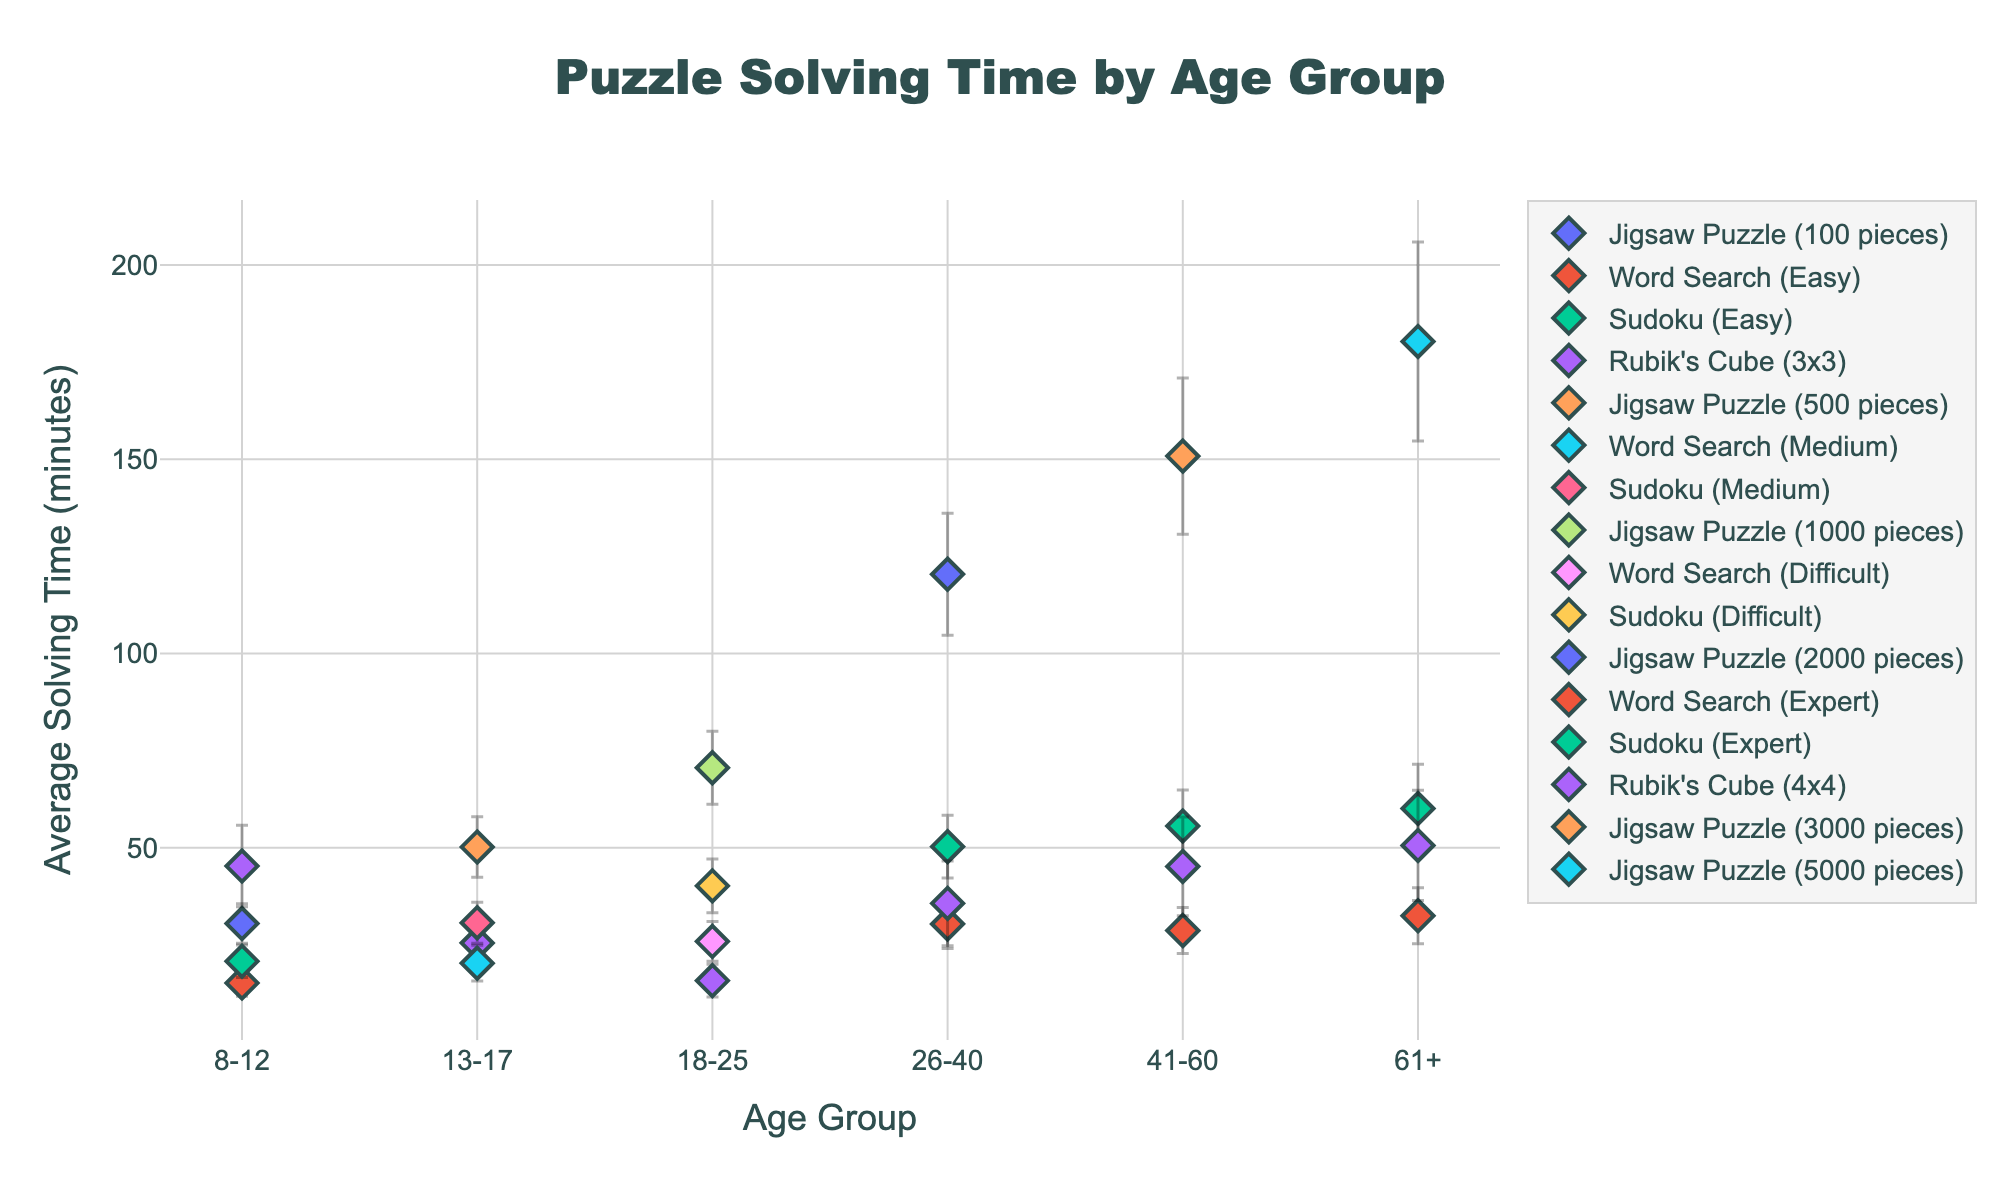What's the title of the plot? The title is centered at the top of the plot, shown in a larger font size.
Answer: Puzzle Solving Time by Age Group What age group has the longest average solving time for Jigsaw Puzzles? By looking at the y-axis values for the diamond markers representing Jigsaw Puzzles, the 61+ age group has the highest value.
Answer: 61+ Which puzzle type has the smallest average solving time for the 18-25 age group? By comparing the y-axis positions of the markers for the 18-25 group, the Rubik's Cube (3x3) has the lowest value.
Answer: Rubik's Cube (3x3) How does the average solving time for a 4x4 Rubik’s Cube vary between the 26-40 and 61+ age groups? Find the markers for the 4x4 Rubik's Cube for both age groups and compare their average solving times.
Answer: The 26-40 group has a lower solving time than the 61+ group Which age group has the highest variability in solving time for Sudoku puzzles? The variability can be inferred from the length of error bars. The 61+ age group has the longest error bars for Sudoku puzzles.
Answer: 61+ What is the average solving time difference for Word Searches between the 8-12 and 61+ groups? Subtract the y-axis value for Word Search of the 8-12 group from the value for the 61+ group.
Answer: 17.3 minutes Which puzzle type has consistently increasing solving times across all age groups? Look for the puzzle type where markers ascend in y-axis value as age increases. Jigsaw Puzzles consistently increase in solving time.
Answer: Jigsaw Puzzles For the 41-60 age group, which puzzle type has the shortest solving time? Check the y-axis values for each marker in the 41-60 age group. Word Search (Expert) has the shortest solving time.
Answer: Word Search (Expert) Is there any age group where the Rubik’s Cube solving time is less than for the previous age group? If so, which? Compare the y-axis values of Rubik's Cube markers for consecutive age groups. The 13-17 age group has a lower solving time than the 8-12 group.
Answer: 13-17 